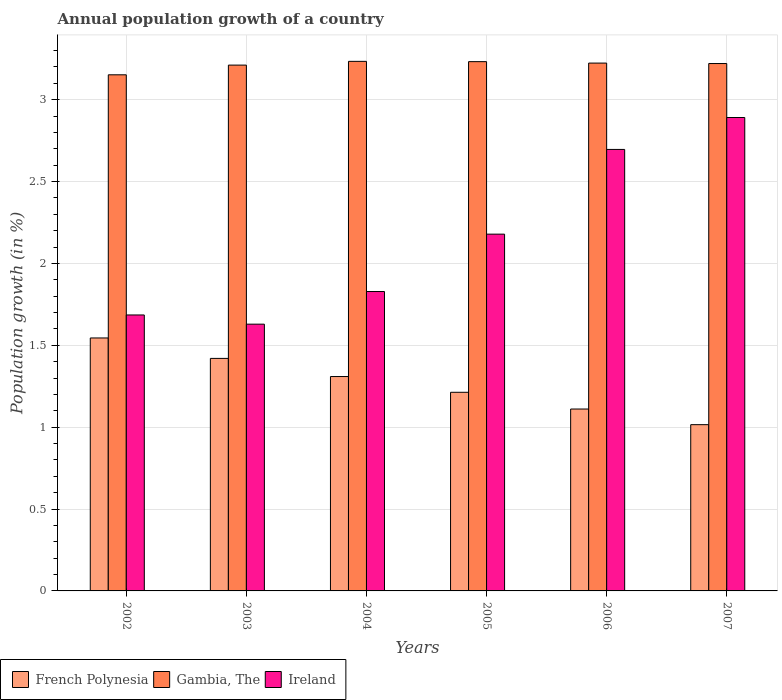How many different coloured bars are there?
Offer a very short reply. 3. How many groups of bars are there?
Offer a very short reply. 6. Are the number of bars per tick equal to the number of legend labels?
Your response must be concise. Yes. Are the number of bars on each tick of the X-axis equal?
Offer a terse response. Yes. What is the annual population growth in French Polynesia in 2003?
Your answer should be compact. 1.42. Across all years, what is the maximum annual population growth in Ireland?
Ensure brevity in your answer.  2.89. Across all years, what is the minimum annual population growth in Ireland?
Offer a terse response. 1.63. In which year was the annual population growth in Gambia, The minimum?
Give a very brief answer. 2002. What is the total annual population growth in French Polynesia in the graph?
Offer a very short reply. 7.61. What is the difference between the annual population growth in French Polynesia in 2003 and that in 2005?
Provide a short and direct response. 0.21. What is the difference between the annual population growth in French Polynesia in 2007 and the annual population growth in Gambia, The in 2005?
Provide a short and direct response. -2.22. What is the average annual population growth in French Polynesia per year?
Ensure brevity in your answer.  1.27. In the year 2005, what is the difference between the annual population growth in French Polynesia and annual population growth in Ireland?
Make the answer very short. -0.97. What is the ratio of the annual population growth in Ireland in 2002 to that in 2005?
Your answer should be compact. 0.77. What is the difference between the highest and the second highest annual population growth in French Polynesia?
Ensure brevity in your answer.  0.12. What is the difference between the highest and the lowest annual population growth in French Polynesia?
Provide a short and direct response. 0.53. Is the sum of the annual population growth in Gambia, The in 2005 and 2007 greater than the maximum annual population growth in French Polynesia across all years?
Your response must be concise. Yes. What does the 3rd bar from the left in 2003 represents?
Provide a succinct answer. Ireland. What does the 2nd bar from the right in 2002 represents?
Your answer should be very brief. Gambia, The. Is it the case that in every year, the sum of the annual population growth in Ireland and annual population growth in Gambia, The is greater than the annual population growth in French Polynesia?
Provide a succinct answer. Yes. How many bars are there?
Provide a succinct answer. 18. How many years are there in the graph?
Provide a short and direct response. 6. Does the graph contain grids?
Your response must be concise. Yes. How are the legend labels stacked?
Provide a succinct answer. Horizontal. What is the title of the graph?
Ensure brevity in your answer.  Annual population growth of a country. What is the label or title of the X-axis?
Offer a terse response. Years. What is the label or title of the Y-axis?
Your answer should be very brief. Population growth (in %). What is the Population growth (in %) in French Polynesia in 2002?
Offer a terse response. 1.54. What is the Population growth (in %) in Gambia, The in 2002?
Provide a succinct answer. 3.15. What is the Population growth (in %) in Ireland in 2002?
Your response must be concise. 1.69. What is the Population growth (in %) in French Polynesia in 2003?
Keep it short and to the point. 1.42. What is the Population growth (in %) in Gambia, The in 2003?
Give a very brief answer. 3.21. What is the Population growth (in %) of Ireland in 2003?
Give a very brief answer. 1.63. What is the Population growth (in %) in French Polynesia in 2004?
Your answer should be compact. 1.31. What is the Population growth (in %) in Gambia, The in 2004?
Give a very brief answer. 3.23. What is the Population growth (in %) in Ireland in 2004?
Your response must be concise. 1.83. What is the Population growth (in %) of French Polynesia in 2005?
Make the answer very short. 1.21. What is the Population growth (in %) in Gambia, The in 2005?
Your answer should be compact. 3.23. What is the Population growth (in %) in Ireland in 2005?
Offer a very short reply. 2.18. What is the Population growth (in %) in French Polynesia in 2006?
Keep it short and to the point. 1.11. What is the Population growth (in %) of Gambia, The in 2006?
Keep it short and to the point. 3.22. What is the Population growth (in %) of Ireland in 2006?
Ensure brevity in your answer.  2.7. What is the Population growth (in %) of French Polynesia in 2007?
Your answer should be very brief. 1.02. What is the Population growth (in %) of Gambia, The in 2007?
Your answer should be very brief. 3.22. What is the Population growth (in %) of Ireland in 2007?
Provide a succinct answer. 2.89. Across all years, what is the maximum Population growth (in %) in French Polynesia?
Provide a succinct answer. 1.54. Across all years, what is the maximum Population growth (in %) of Gambia, The?
Your answer should be very brief. 3.23. Across all years, what is the maximum Population growth (in %) in Ireland?
Your answer should be compact. 2.89. Across all years, what is the minimum Population growth (in %) in French Polynesia?
Ensure brevity in your answer.  1.02. Across all years, what is the minimum Population growth (in %) in Gambia, The?
Ensure brevity in your answer.  3.15. Across all years, what is the minimum Population growth (in %) in Ireland?
Ensure brevity in your answer.  1.63. What is the total Population growth (in %) in French Polynesia in the graph?
Provide a succinct answer. 7.61. What is the total Population growth (in %) of Gambia, The in the graph?
Provide a succinct answer. 19.27. What is the total Population growth (in %) in Ireland in the graph?
Provide a short and direct response. 12.91. What is the difference between the Population growth (in %) in French Polynesia in 2002 and that in 2003?
Keep it short and to the point. 0.12. What is the difference between the Population growth (in %) in Gambia, The in 2002 and that in 2003?
Provide a short and direct response. -0.06. What is the difference between the Population growth (in %) of Ireland in 2002 and that in 2003?
Provide a short and direct response. 0.06. What is the difference between the Population growth (in %) of French Polynesia in 2002 and that in 2004?
Give a very brief answer. 0.24. What is the difference between the Population growth (in %) of Gambia, The in 2002 and that in 2004?
Your answer should be very brief. -0.08. What is the difference between the Population growth (in %) in Ireland in 2002 and that in 2004?
Your answer should be very brief. -0.14. What is the difference between the Population growth (in %) of French Polynesia in 2002 and that in 2005?
Make the answer very short. 0.33. What is the difference between the Population growth (in %) of Gambia, The in 2002 and that in 2005?
Provide a short and direct response. -0.08. What is the difference between the Population growth (in %) of Ireland in 2002 and that in 2005?
Provide a succinct answer. -0.49. What is the difference between the Population growth (in %) in French Polynesia in 2002 and that in 2006?
Offer a terse response. 0.43. What is the difference between the Population growth (in %) of Gambia, The in 2002 and that in 2006?
Offer a very short reply. -0.07. What is the difference between the Population growth (in %) of Ireland in 2002 and that in 2006?
Make the answer very short. -1.01. What is the difference between the Population growth (in %) in French Polynesia in 2002 and that in 2007?
Keep it short and to the point. 0.53. What is the difference between the Population growth (in %) of Gambia, The in 2002 and that in 2007?
Keep it short and to the point. -0.07. What is the difference between the Population growth (in %) in Ireland in 2002 and that in 2007?
Keep it short and to the point. -1.21. What is the difference between the Population growth (in %) in French Polynesia in 2003 and that in 2004?
Your response must be concise. 0.11. What is the difference between the Population growth (in %) of Gambia, The in 2003 and that in 2004?
Your answer should be very brief. -0.02. What is the difference between the Population growth (in %) of Ireland in 2003 and that in 2004?
Give a very brief answer. -0.2. What is the difference between the Population growth (in %) in French Polynesia in 2003 and that in 2005?
Ensure brevity in your answer.  0.21. What is the difference between the Population growth (in %) in Gambia, The in 2003 and that in 2005?
Provide a succinct answer. -0.02. What is the difference between the Population growth (in %) of Ireland in 2003 and that in 2005?
Offer a terse response. -0.55. What is the difference between the Population growth (in %) in French Polynesia in 2003 and that in 2006?
Offer a terse response. 0.31. What is the difference between the Population growth (in %) in Gambia, The in 2003 and that in 2006?
Offer a very short reply. -0.01. What is the difference between the Population growth (in %) in Ireland in 2003 and that in 2006?
Your answer should be compact. -1.07. What is the difference between the Population growth (in %) in French Polynesia in 2003 and that in 2007?
Your answer should be compact. 0.4. What is the difference between the Population growth (in %) of Gambia, The in 2003 and that in 2007?
Make the answer very short. -0.01. What is the difference between the Population growth (in %) of Ireland in 2003 and that in 2007?
Provide a succinct answer. -1.26. What is the difference between the Population growth (in %) of French Polynesia in 2004 and that in 2005?
Your answer should be compact. 0.1. What is the difference between the Population growth (in %) of Gambia, The in 2004 and that in 2005?
Offer a very short reply. 0. What is the difference between the Population growth (in %) in Ireland in 2004 and that in 2005?
Ensure brevity in your answer.  -0.35. What is the difference between the Population growth (in %) of French Polynesia in 2004 and that in 2006?
Provide a short and direct response. 0.2. What is the difference between the Population growth (in %) in Gambia, The in 2004 and that in 2006?
Your answer should be compact. 0.01. What is the difference between the Population growth (in %) of Ireland in 2004 and that in 2006?
Provide a short and direct response. -0.87. What is the difference between the Population growth (in %) of French Polynesia in 2004 and that in 2007?
Provide a succinct answer. 0.29. What is the difference between the Population growth (in %) in Gambia, The in 2004 and that in 2007?
Your response must be concise. 0.01. What is the difference between the Population growth (in %) of Ireland in 2004 and that in 2007?
Provide a succinct answer. -1.06. What is the difference between the Population growth (in %) of French Polynesia in 2005 and that in 2006?
Your response must be concise. 0.1. What is the difference between the Population growth (in %) of Gambia, The in 2005 and that in 2006?
Your answer should be compact. 0.01. What is the difference between the Population growth (in %) of Ireland in 2005 and that in 2006?
Keep it short and to the point. -0.52. What is the difference between the Population growth (in %) of French Polynesia in 2005 and that in 2007?
Give a very brief answer. 0.2. What is the difference between the Population growth (in %) in Gambia, The in 2005 and that in 2007?
Offer a very short reply. 0.01. What is the difference between the Population growth (in %) of Ireland in 2005 and that in 2007?
Provide a succinct answer. -0.71. What is the difference between the Population growth (in %) in French Polynesia in 2006 and that in 2007?
Provide a succinct answer. 0.1. What is the difference between the Population growth (in %) in Gambia, The in 2006 and that in 2007?
Make the answer very short. 0. What is the difference between the Population growth (in %) of Ireland in 2006 and that in 2007?
Your answer should be compact. -0.2. What is the difference between the Population growth (in %) of French Polynesia in 2002 and the Population growth (in %) of Gambia, The in 2003?
Make the answer very short. -1.67. What is the difference between the Population growth (in %) in French Polynesia in 2002 and the Population growth (in %) in Ireland in 2003?
Offer a very short reply. -0.08. What is the difference between the Population growth (in %) in Gambia, The in 2002 and the Population growth (in %) in Ireland in 2003?
Provide a succinct answer. 1.52. What is the difference between the Population growth (in %) of French Polynesia in 2002 and the Population growth (in %) of Gambia, The in 2004?
Your answer should be very brief. -1.69. What is the difference between the Population growth (in %) of French Polynesia in 2002 and the Population growth (in %) of Ireland in 2004?
Offer a terse response. -0.28. What is the difference between the Population growth (in %) in Gambia, The in 2002 and the Population growth (in %) in Ireland in 2004?
Ensure brevity in your answer.  1.32. What is the difference between the Population growth (in %) in French Polynesia in 2002 and the Population growth (in %) in Gambia, The in 2005?
Make the answer very short. -1.69. What is the difference between the Population growth (in %) in French Polynesia in 2002 and the Population growth (in %) in Ireland in 2005?
Give a very brief answer. -0.63. What is the difference between the Population growth (in %) in French Polynesia in 2002 and the Population growth (in %) in Gambia, The in 2006?
Your answer should be very brief. -1.68. What is the difference between the Population growth (in %) in French Polynesia in 2002 and the Population growth (in %) in Ireland in 2006?
Ensure brevity in your answer.  -1.15. What is the difference between the Population growth (in %) in Gambia, The in 2002 and the Population growth (in %) in Ireland in 2006?
Give a very brief answer. 0.46. What is the difference between the Population growth (in %) of French Polynesia in 2002 and the Population growth (in %) of Gambia, The in 2007?
Your answer should be compact. -1.68. What is the difference between the Population growth (in %) of French Polynesia in 2002 and the Population growth (in %) of Ireland in 2007?
Provide a short and direct response. -1.35. What is the difference between the Population growth (in %) in Gambia, The in 2002 and the Population growth (in %) in Ireland in 2007?
Make the answer very short. 0.26. What is the difference between the Population growth (in %) in French Polynesia in 2003 and the Population growth (in %) in Gambia, The in 2004?
Offer a very short reply. -1.81. What is the difference between the Population growth (in %) of French Polynesia in 2003 and the Population growth (in %) of Ireland in 2004?
Keep it short and to the point. -0.41. What is the difference between the Population growth (in %) of Gambia, The in 2003 and the Population growth (in %) of Ireland in 2004?
Ensure brevity in your answer.  1.38. What is the difference between the Population growth (in %) in French Polynesia in 2003 and the Population growth (in %) in Gambia, The in 2005?
Your answer should be compact. -1.81. What is the difference between the Population growth (in %) in French Polynesia in 2003 and the Population growth (in %) in Ireland in 2005?
Provide a succinct answer. -0.76. What is the difference between the Population growth (in %) of Gambia, The in 2003 and the Population growth (in %) of Ireland in 2005?
Provide a short and direct response. 1.03. What is the difference between the Population growth (in %) in French Polynesia in 2003 and the Population growth (in %) in Gambia, The in 2006?
Offer a terse response. -1.8. What is the difference between the Population growth (in %) of French Polynesia in 2003 and the Population growth (in %) of Ireland in 2006?
Offer a very short reply. -1.28. What is the difference between the Population growth (in %) of Gambia, The in 2003 and the Population growth (in %) of Ireland in 2006?
Offer a terse response. 0.52. What is the difference between the Population growth (in %) in French Polynesia in 2003 and the Population growth (in %) in Gambia, The in 2007?
Keep it short and to the point. -1.8. What is the difference between the Population growth (in %) of French Polynesia in 2003 and the Population growth (in %) of Ireland in 2007?
Provide a succinct answer. -1.47. What is the difference between the Population growth (in %) in Gambia, The in 2003 and the Population growth (in %) in Ireland in 2007?
Give a very brief answer. 0.32. What is the difference between the Population growth (in %) in French Polynesia in 2004 and the Population growth (in %) in Gambia, The in 2005?
Ensure brevity in your answer.  -1.92. What is the difference between the Population growth (in %) of French Polynesia in 2004 and the Population growth (in %) of Ireland in 2005?
Your answer should be compact. -0.87. What is the difference between the Population growth (in %) in Gambia, The in 2004 and the Population growth (in %) in Ireland in 2005?
Your response must be concise. 1.06. What is the difference between the Population growth (in %) in French Polynesia in 2004 and the Population growth (in %) in Gambia, The in 2006?
Offer a terse response. -1.91. What is the difference between the Population growth (in %) of French Polynesia in 2004 and the Population growth (in %) of Ireland in 2006?
Offer a terse response. -1.39. What is the difference between the Population growth (in %) of Gambia, The in 2004 and the Population growth (in %) of Ireland in 2006?
Give a very brief answer. 0.54. What is the difference between the Population growth (in %) of French Polynesia in 2004 and the Population growth (in %) of Gambia, The in 2007?
Give a very brief answer. -1.91. What is the difference between the Population growth (in %) of French Polynesia in 2004 and the Population growth (in %) of Ireland in 2007?
Ensure brevity in your answer.  -1.58. What is the difference between the Population growth (in %) of Gambia, The in 2004 and the Population growth (in %) of Ireland in 2007?
Your answer should be compact. 0.34. What is the difference between the Population growth (in %) of French Polynesia in 2005 and the Population growth (in %) of Gambia, The in 2006?
Provide a short and direct response. -2.01. What is the difference between the Population growth (in %) of French Polynesia in 2005 and the Population growth (in %) of Ireland in 2006?
Your response must be concise. -1.48. What is the difference between the Population growth (in %) of Gambia, The in 2005 and the Population growth (in %) of Ireland in 2006?
Offer a very short reply. 0.54. What is the difference between the Population growth (in %) in French Polynesia in 2005 and the Population growth (in %) in Gambia, The in 2007?
Offer a terse response. -2.01. What is the difference between the Population growth (in %) in French Polynesia in 2005 and the Population growth (in %) in Ireland in 2007?
Your answer should be very brief. -1.68. What is the difference between the Population growth (in %) of Gambia, The in 2005 and the Population growth (in %) of Ireland in 2007?
Give a very brief answer. 0.34. What is the difference between the Population growth (in %) of French Polynesia in 2006 and the Population growth (in %) of Gambia, The in 2007?
Offer a very short reply. -2.11. What is the difference between the Population growth (in %) of French Polynesia in 2006 and the Population growth (in %) of Ireland in 2007?
Provide a short and direct response. -1.78. What is the difference between the Population growth (in %) of Gambia, The in 2006 and the Population growth (in %) of Ireland in 2007?
Provide a short and direct response. 0.33. What is the average Population growth (in %) of French Polynesia per year?
Offer a very short reply. 1.27. What is the average Population growth (in %) in Gambia, The per year?
Give a very brief answer. 3.21. What is the average Population growth (in %) in Ireland per year?
Offer a terse response. 2.15. In the year 2002, what is the difference between the Population growth (in %) of French Polynesia and Population growth (in %) of Gambia, The?
Your response must be concise. -1.61. In the year 2002, what is the difference between the Population growth (in %) in French Polynesia and Population growth (in %) in Ireland?
Provide a short and direct response. -0.14. In the year 2002, what is the difference between the Population growth (in %) of Gambia, The and Population growth (in %) of Ireland?
Ensure brevity in your answer.  1.47. In the year 2003, what is the difference between the Population growth (in %) in French Polynesia and Population growth (in %) in Gambia, The?
Ensure brevity in your answer.  -1.79. In the year 2003, what is the difference between the Population growth (in %) of French Polynesia and Population growth (in %) of Ireland?
Give a very brief answer. -0.21. In the year 2003, what is the difference between the Population growth (in %) of Gambia, The and Population growth (in %) of Ireland?
Offer a terse response. 1.58. In the year 2004, what is the difference between the Population growth (in %) in French Polynesia and Population growth (in %) in Gambia, The?
Give a very brief answer. -1.92. In the year 2004, what is the difference between the Population growth (in %) in French Polynesia and Population growth (in %) in Ireland?
Ensure brevity in your answer.  -0.52. In the year 2004, what is the difference between the Population growth (in %) of Gambia, The and Population growth (in %) of Ireland?
Your response must be concise. 1.41. In the year 2005, what is the difference between the Population growth (in %) in French Polynesia and Population growth (in %) in Gambia, The?
Give a very brief answer. -2.02. In the year 2005, what is the difference between the Population growth (in %) of French Polynesia and Population growth (in %) of Ireland?
Your response must be concise. -0.97. In the year 2005, what is the difference between the Population growth (in %) in Gambia, The and Population growth (in %) in Ireland?
Make the answer very short. 1.05. In the year 2006, what is the difference between the Population growth (in %) in French Polynesia and Population growth (in %) in Gambia, The?
Offer a terse response. -2.11. In the year 2006, what is the difference between the Population growth (in %) in French Polynesia and Population growth (in %) in Ireland?
Keep it short and to the point. -1.59. In the year 2006, what is the difference between the Population growth (in %) in Gambia, The and Population growth (in %) in Ireland?
Offer a terse response. 0.53. In the year 2007, what is the difference between the Population growth (in %) in French Polynesia and Population growth (in %) in Gambia, The?
Keep it short and to the point. -2.21. In the year 2007, what is the difference between the Population growth (in %) of French Polynesia and Population growth (in %) of Ireland?
Give a very brief answer. -1.88. In the year 2007, what is the difference between the Population growth (in %) of Gambia, The and Population growth (in %) of Ireland?
Your response must be concise. 0.33. What is the ratio of the Population growth (in %) in French Polynesia in 2002 to that in 2003?
Offer a terse response. 1.09. What is the ratio of the Population growth (in %) of Gambia, The in 2002 to that in 2003?
Give a very brief answer. 0.98. What is the ratio of the Population growth (in %) of Ireland in 2002 to that in 2003?
Your answer should be very brief. 1.03. What is the ratio of the Population growth (in %) of French Polynesia in 2002 to that in 2004?
Give a very brief answer. 1.18. What is the ratio of the Population growth (in %) in Gambia, The in 2002 to that in 2004?
Give a very brief answer. 0.97. What is the ratio of the Population growth (in %) of Ireland in 2002 to that in 2004?
Provide a short and direct response. 0.92. What is the ratio of the Population growth (in %) in French Polynesia in 2002 to that in 2005?
Ensure brevity in your answer.  1.27. What is the ratio of the Population growth (in %) of Gambia, The in 2002 to that in 2005?
Your answer should be compact. 0.98. What is the ratio of the Population growth (in %) of Ireland in 2002 to that in 2005?
Your answer should be compact. 0.77. What is the ratio of the Population growth (in %) in French Polynesia in 2002 to that in 2006?
Keep it short and to the point. 1.39. What is the ratio of the Population growth (in %) in Gambia, The in 2002 to that in 2006?
Ensure brevity in your answer.  0.98. What is the ratio of the Population growth (in %) of Ireland in 2002 to that in 2006?
Your answer should be compact. 0.63. What is the ratio of the Population growth (in %) of French Polynesia in 2002 to that in 2007?
Your answer should be compact. 1.52. What is the ratio of the Population growth (in %) of Gambia, The in 2002 to that in 2007?
Your answer should be compact. 0.98. What is the ratio of the Population growth (in %) of Ireland in 2002 to that in 2007?
Your answer should be compact. 0.58. What is the ratio of the Population growth (in %) in French Polynesia in 2003 to that in 2004?
Give a very brief answer. 1.08. What is the ratio of the Population growth (in %) of Ireland in 2003 to that in 2004?
Ensure brevity in your answer.  0.89. What is the ratio of the Population growth (in %) of French Polynesia in 2003 to that in 2005?
Make the answer very short. 1.17. What is the ratio of the Population growth (in %) in Gambia, The in 2003 to that in 2005?
Ensure brevity in your answer.  0.99. What is the ratio of the Population growth (in %) in Ireland in 2003 to that in 2005?
Offer a terse response. 0.75. What is the ratio of the Population growth (in %) of French Polynesia in 2003 to that in 2006?
Make the answer very short. 1.28. What is the ratio of the Population growth (in %) in Ireland in 2003 to that in 2006?
Keep it short and to the point. 0.6. What is the ratio of the Population growth (in %) in French Polynesia in 2003 to that in 2007?
Keep it short and to the point. 1.4. What is the ratio of the Population growth (in %) in Ireland in 2003 to that in 2007?
Your response must be concise. 0.56. What is the ratio of the Population growth (in %) in French Polynesia in 2004 to that in 2005?
Keep it short and to the point. 1.08. What is the ratio of the Population growth (in %) of Ireland in 2004 to that in 2005?
Provide a succinct answer. 0.84. What is the ratio of the Population growth (in %) in French Polynesia in 2004 to that in 2006?
Offer a very short reply. 1.18. What is the ratio of the Population growth (in %) of Ireland in 2004 to that in 2006?
Offer a terse response. 0.68. What is the ratio of the Population growth (in %) in French Polynesia in 2004 to that in 2007?
Your answer should be compact. 1.29. What is the ratio of the Population growth (in %) of Ireland in 2004 to that in 2007?
Provide a succinct answer. 0.63. What is the ratio of the Population growth (in %) in French Polynesia in 2005 to that in 2006?
Offer a very short reply. 1.09. What is the ratio of the Population growth (in %) of Gambia, The in 2005 to that in 2006?
Provide a succinct answer. 1. What is the ratio of the Population growth (in %) of Ireland in 2005 to that in 2006?
Your answer should be very brief. 0.81. What is the ratio of the Population growth (in %) of French Polynesia in 2005 to that in 2007?
Your response must be concise. 1.19. What is the ratio of the Population growth (in %) in Ireland in 2005 to that in 2007?
Make the answer very short. 0.75. What is the ratio of the Population growth (in %) in French Polynesia in 2006 to that in 2007?
Offer a terse response. 1.09. What is the ratio of the Population growth (in %) of Ireland in 2006 to that in 2007?
Make the answer very short. 0.93. What is the difference between the highest and the second highest Population growth (in %) of French Polynesia?
Your response must be concise. 0.12. What is the difference between the highest and the second highest Population growth (in %) in Gambia, The?
Offer a very short reply. 0. What is the difference between the highest and the second highest Population growth (in %) in Ireland?
Your response must be concise. 0.2. What is the difference between the highest and the lowest Population growth (in %) in French Polynesia?
Your answer should be very brief. 0.53. What is the difference between the highest and the lowest Population growth (in %) in Gambia, The?
Give a very brief answer. 0.08. What is the difference between the highest and the lowest Population growth (in %) in Ireland?
Offer a very short reply. 1.26. 